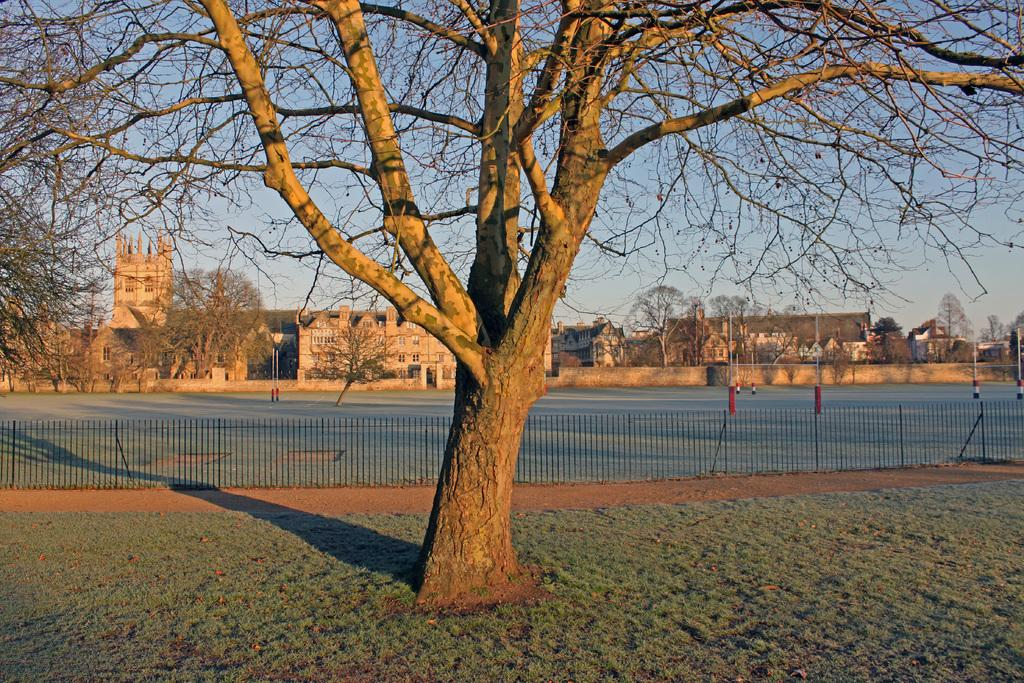What type of surface is on the ground in the image? There is grass on the ground in the image. What can be seen in the background of the image? There is a fence, buildings, trees, and the sky visible in the background of the image. Can you describe the unspecified objects in the background of the image? Unfortunately, the provided facts do not specify the nature of the unspecified objects in the background. What type of soup is being served on the sofa in the image? There is no sofa or soup present in the image. How does the control panel on the left side of the image affect the scene? There is no control panel present in the image. 